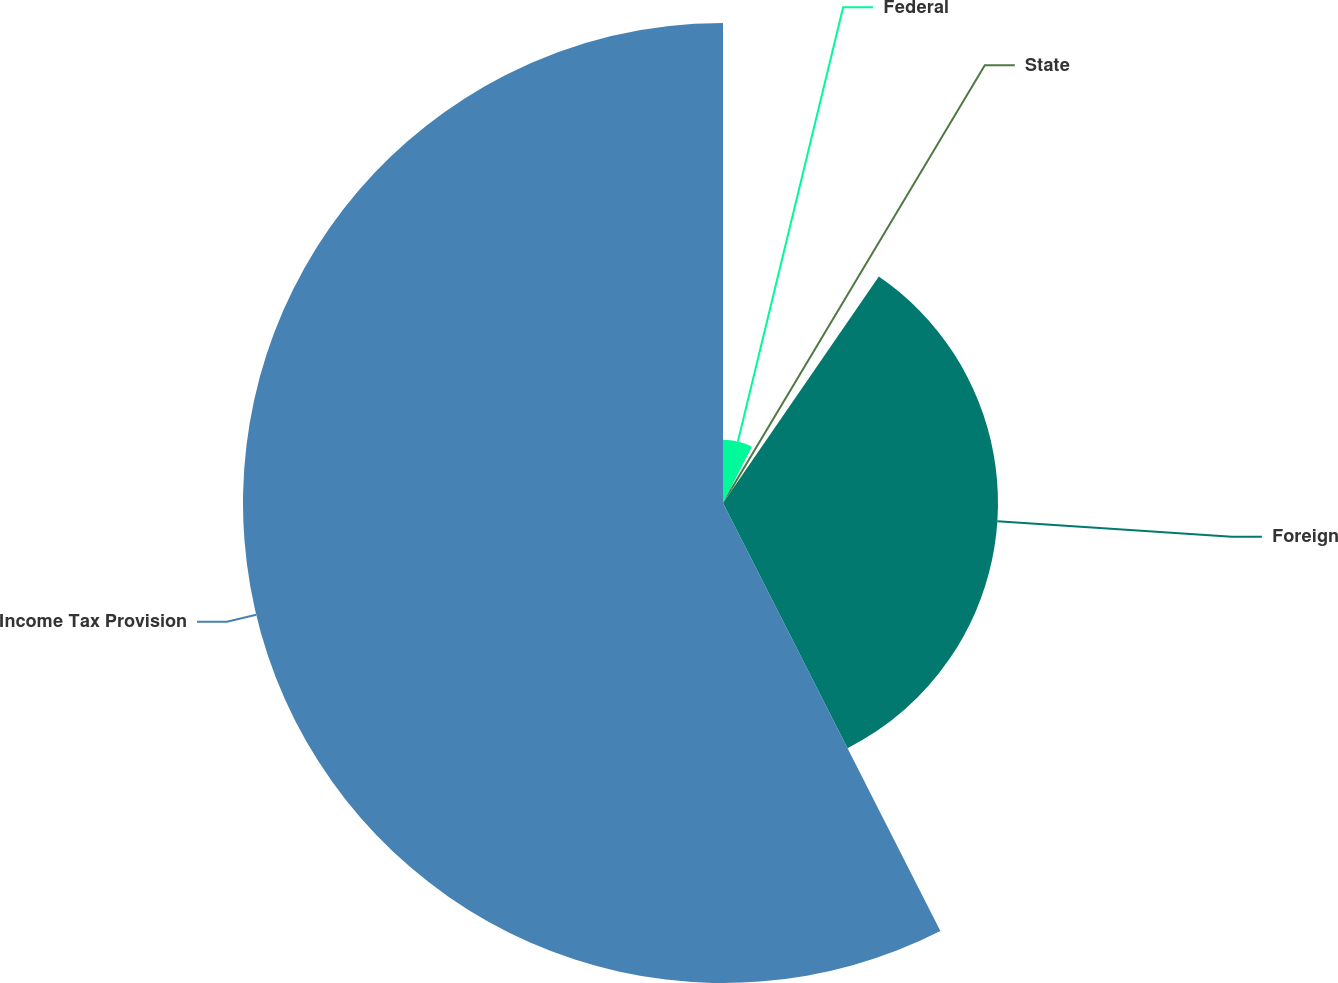Convert chart to OTSL. <chart><loc_0><loc_0><loc_500><loc_500><pie_chart><fcel>Federal<fcel>State<fcel>Foreign<fcel>Income Tax Provision<nl><fcel>7.57%<fcel>2.02%<fcel>32.93%<fcel>57.48%<nl></chart> 